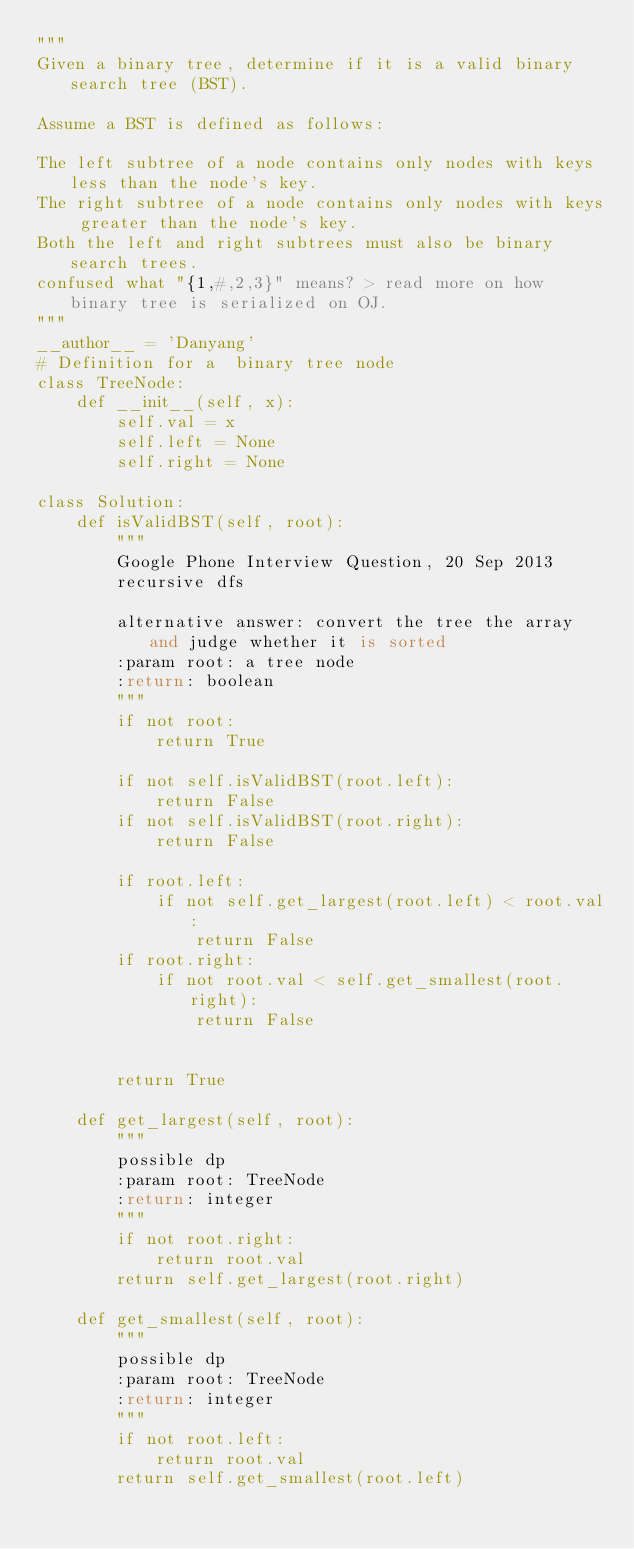<code> <loc_0><loc_0><loc_500><loc_500><_Python_>"""
Given a binary tree, determine if it is a valid binary search tree (BST).

Assume a BST is defined as follows:

The left subtree of a node contains only nodes with keys less than the node's key.
The right subtree of a node contains only nodes with keys greater than the node's key.
Both the left and right subtrees must also be binary search trees.
confused what "{1,#,2,3}" means? > read more on how binary tree is serialized on OJ.
"""
__author__ = 'Danyang'
# Definition for a  binary tree node
class TreeNode:
    def __init__(self, x):
        self.val = x
        self.left = None
        self.right = None

class Solution:
    def isValidBST(self, root):
        """
        Google Phone Interview Question, 20 Sep 2013
        recursive dfs

        alternative answer: convert the tree the array and judge whether it is sorted
        :param root: a tree node
        :return: boolean
        """
        if not root:
            return True

        if not self.isValidBST(root.left):
            return False
        if not self.isValidBST(root.right):
            return False

        if root.left:
            if not self.get_largest(root.left) < root.val:
                return False
        if root.right:
            if not root.val < self.get_smallest(root.right):
                return False


        return True

    def get_largest(self, root):
        """
        possible dp
        :param root: TreeNode
        :return: integer
        """
        if not root.right:
            return root.val
        return self.get_largest(root.right)

    def get_smallest(self, root):
        """
        possible dp
        :param root: TreeNode
        :return: integer
        """
        if not root.left:
            return root.val
        return self.get_smallest(root.left)



</code> 